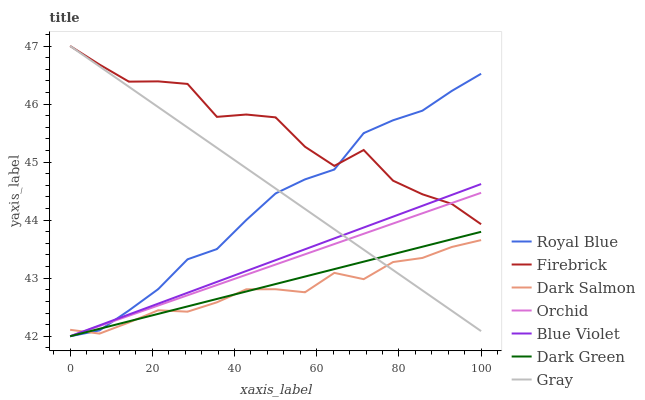Does Dark Salmon have the minimum area under the curve?
Answer yes or no. Yes. Does Firebrick have the maximum area under the curve?
Answer yes or no. Yes. Does Firebrick have the minimum area under the curve?
Answer yes or no. No. Does Dark Salmon have the maximum area under the curve?
Answer yes or no. No. Is Orchid the smoothest?
Answer yes or no. Yes. Is Firebrick the roughest?
Answer yes or no. Yes. Is Dark Salmon the smoothest?
Answer yes or no. No. Is Dark Salmon the roughest?
Answer yes or no. No. Does Royal Blue have the lowest value?
Answer yes or no. Yes. Does Dark Salmon have the lowest value?
Answer yes or no. No. Does Firebrick have the highest value?
Answer yes or no. Yes. Does Dark Salmon have the highest value?
Answer yes or no. No. Is Dark Green less than Firebrick?
Answer yes or no. Yes. Is Firebrick greater than Dark Green?
Answer yes or no. Yes. Does Dark Green intersect Blue Violet?
Answer yes or no. Yes. Is Dark Green less than Blue Violet?
Answer yes or no. No. Is Dark Green greater than Blue Violet?
Answer yes or no. No. Does Dark Green intersect Firebrick?
Answer yes or no. No. 